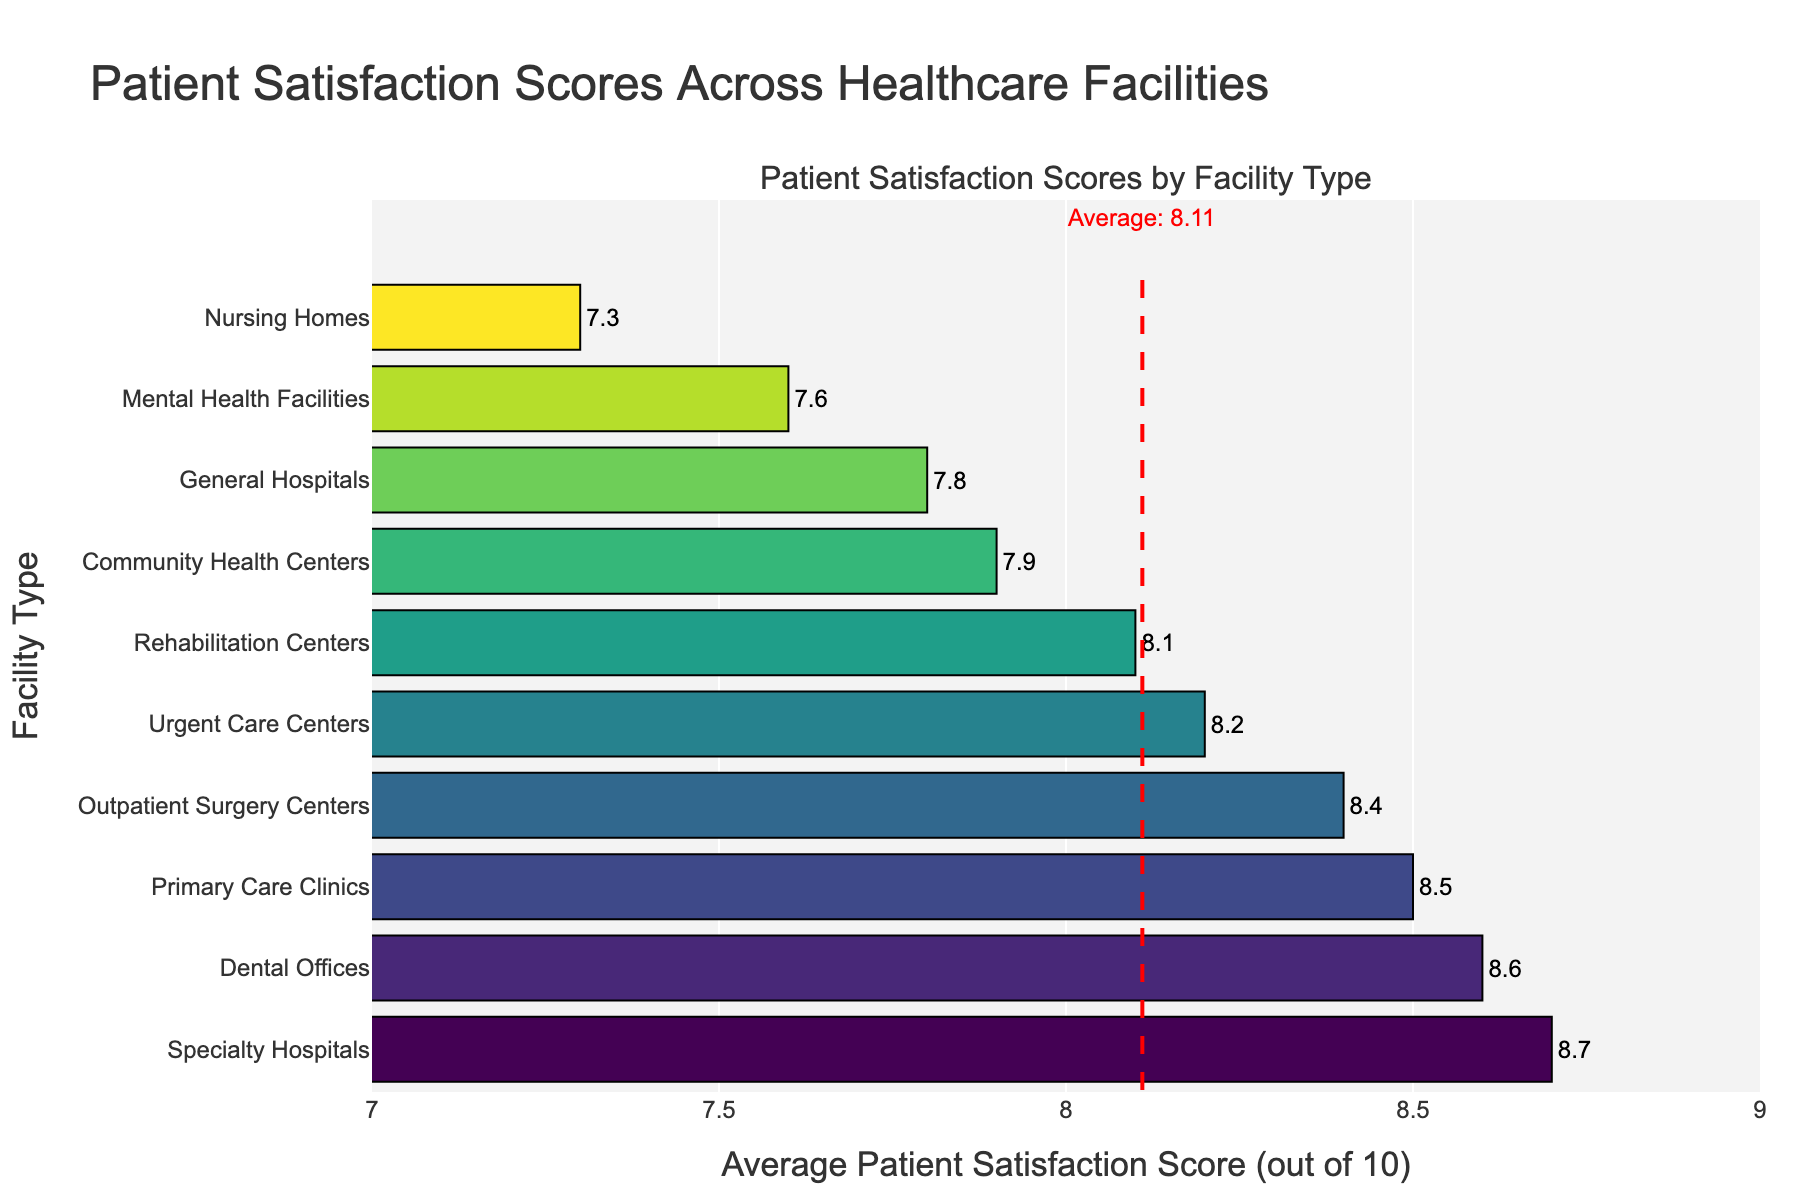Which facility type has the highest patient satisfaction score? The bar representing Specialty Hospitals is to the rightmost, indicating the highest average satisfaction score.
Answer: Specialty Hospitals Which facility type has the lowest patient satisfaction score? The bar for Nursing Homes is the shortest, indicating the lowest average satisfaction score among the listed facilities.
Answer: Nursing Homes How much higher is the average satisfaction score for Primary Care Clinics compared to Nursing Homes? The score for Primary Care Clinics is 8.5, and for Nursing Homes, it is 7.3. Subtracting the Nursing Homes score from the Primary Care Clinics score gives 8.5 - 7.3.
Answer: 1.2 What is the average patient satisfaction score across all healthcare facilities? The red dashed line in the figure denotes the average score, and the annotation indicates the value is 8.01.
Answer: 8.01 Which facility type has a patient satisfaction score that is closest to the overall average? Community Health Centers have a score of 7.9, which is closest to the overall average of 8.01 when compared to other facilities.
Answer: Community Health Centers Is the patient satisfaction score for Dental Offices higher or lower than Outpatient Surgery Centers? The bar for Dental Offices extends further to the right compared to Outpatient Surgery Centers, indicating a higher score for Dental Offices.
Answer: Higher How many facility types have a patient satisfaction score above 8.0? By observing the bars extending beyond the 8.0 mark, we see that there are six facility types: Urgent Care Centers, Primary Care Clinics, Specialty Hospitals, Outpatient Surgery Centers, Rehabilitation Centers, and Dental Offices.
Answer: Six What is the range of patient satisfaction scores in the chart? The highest score is 8.7 (Specialty Hospitals) and the lowest is 7.3 (Nursing Homes). The range is calculated as 8.7 - 7.3.
Answer: 1.4 Are there more facility types with patient satisfaction scores below the average or above the average? By counting the bars relative to the red dashed average line at 8.01, we find there are five facility types above and five below the average. Hence, the numbers are equal.
Answer: Equal Which facility types have a satisfaction score within 0.2 points of the highest score? The highest score is 8.7. Facility types with scores within 0.2 points are those with scores between 8.5 to 8.7. Specialty Hospitals and Dental Offices fall within this range.
Answer: Specialty Hospitals, Dental Offices 